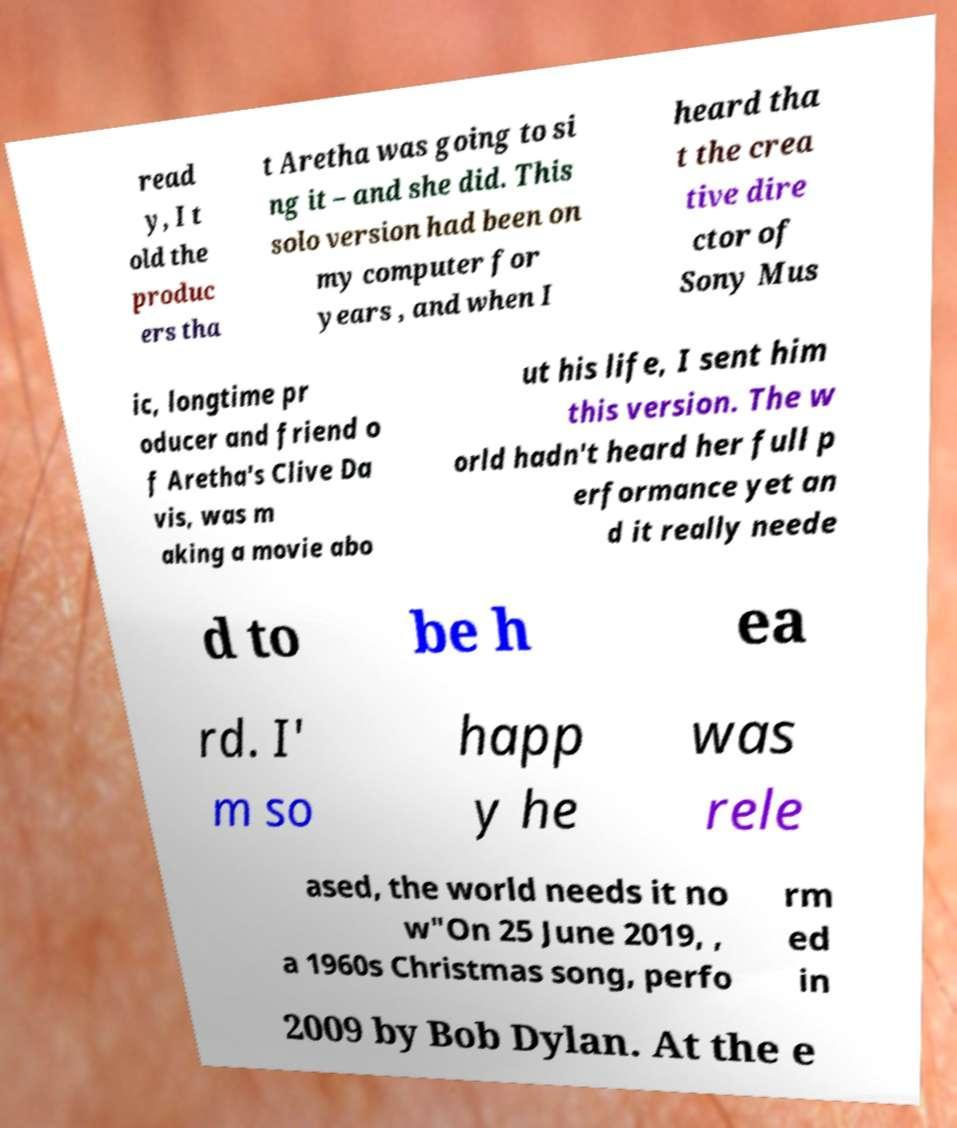Could you extract and type out the text from this image? read y, I t old the produc ers tha t Aretha was going to si ng it – and she did. This solo version had been on my computer for years , and when I heard tha t the crea tive dire ctor of Sony Mus ic, longtime pr oducer and friend o f Aretha's Clive Da vis, was m aking a movie abo ut his life, I sent him this version. The w orld hadn't heard her full p erformance yet an d it really neede d to be h ea rd. I' m so happ y he was rele ased, the world needs it no w"On 25 June 2019, , a 1960s Christmas song, perfo rm ed in 2009 by Bob Dylan. At the e 